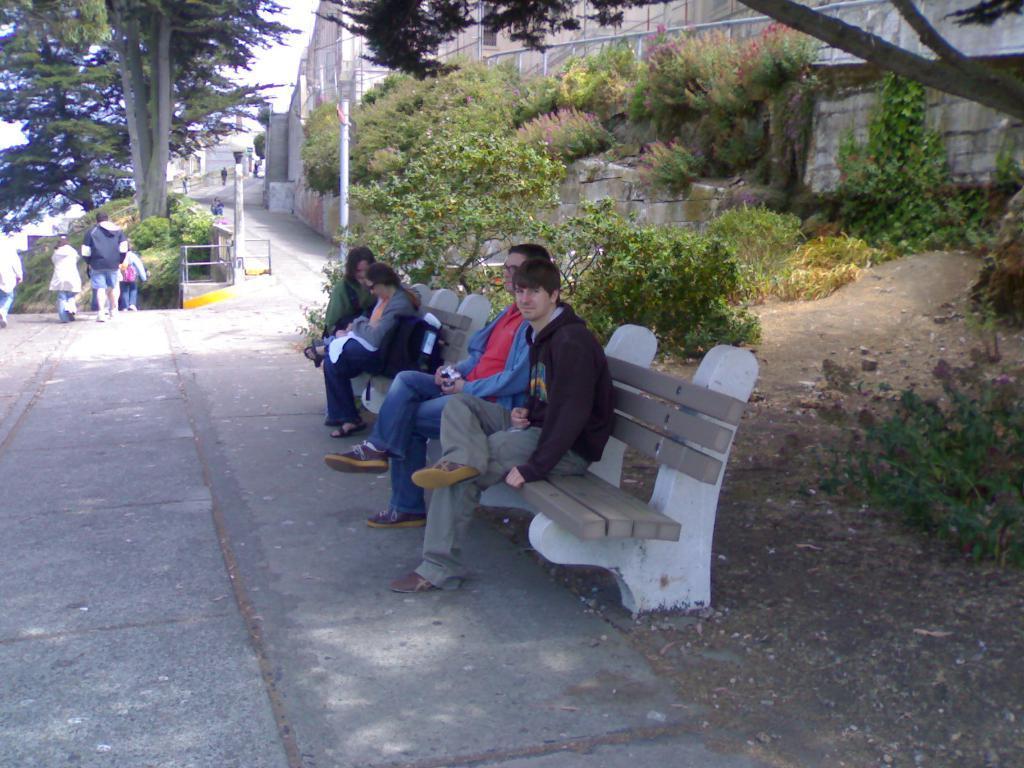How would you summarize this image in a sentence or two? In this picture in the front there are persons sitting on the bench. On the right side there are plants and there is a wall. In the background there are persons walking, there are trees and buildings and there is a railing. 